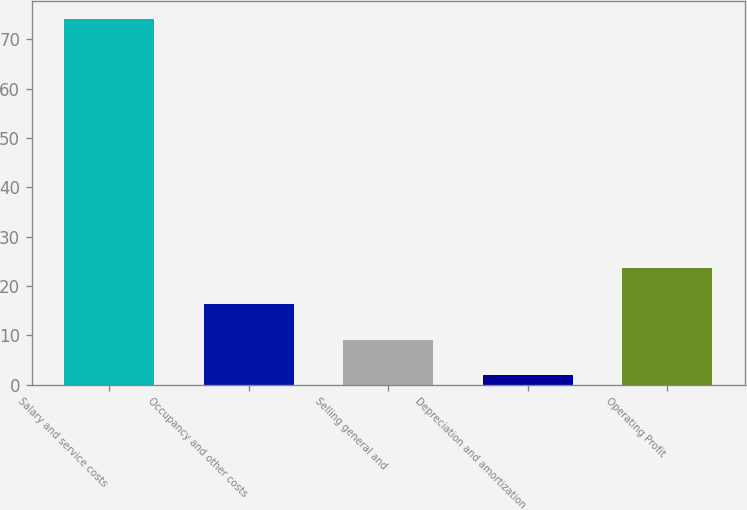Convert chart to OTSL. <chart><loc_0><loc_0><loc_500><loc_500><bar_chart><fcel>Salary and service costs<fcel>Occupancy and other costs<fcel>Selling general and<fcel>Depreciation and amortization<fcel>Operating Profit<nl><fcel>74.1<fcel>16.34<fcel>9.12<fcel>1.9<fcel>23.56<nl></chart> 